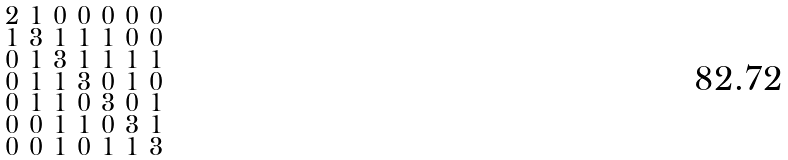Convert formula to latex. <formula><loc_0><loc_0><loc_500><loc_500>\begin{smallmatrix} 2 & 1 & 0 & 0 & 0 & 0 & 0 \\ 1 & 3 & 1 & 1 & 1 & 0 & 0 \\ 0 & 1 & 3 & 1 & 1 & 1 & 1 \\ 0 & 1 & 1 & 3 & 0 & 1 & 0 \\ 0 & 1 & 1 & 0 & 3 & 0 & 1 \\ 0 & 0 & 1 & 1 & 0 & 3 & 1 \\ 0 & 0 & 1 & 0 & 1 & 1 & 3 \end{smallmatrix}</formula> 